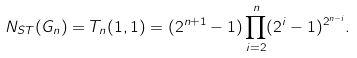<formula> <loc_0><loc_0><loc_500><loc_500>N _ { S T } ( G _ { n } ) = T _ { n } ( 1 , 1 ) = ( 2 ^ { n + 1 } - 1 ) \prod _ { i = 2 } ^ { n } ( 2 ^ { i } - 1 ) ^ { 2 ^ { n - i } } .</formula> 